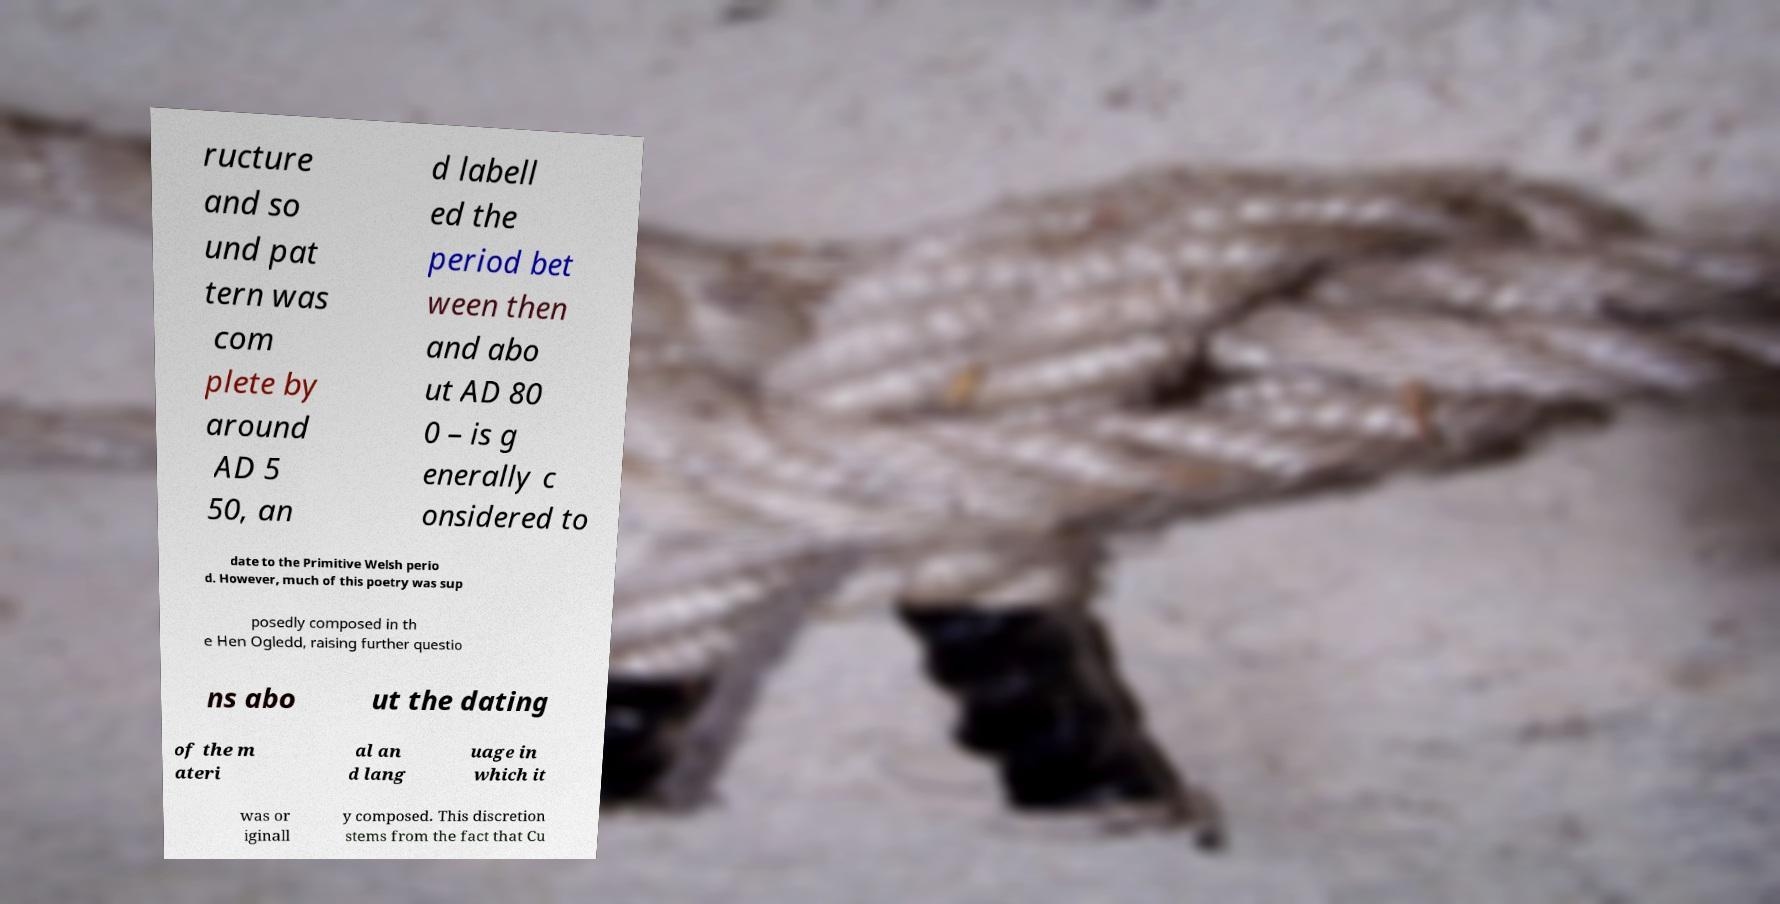Please identify and transcribe the text found in this image. ructure and so und pat tern was com plete by around AD 5 50, an d labell ed the period bet ween then and abo ut AD 80 0 – is g enerally c onsidered to date to the Primitive Welsh perio d. However, much of this poetry was sup posedly composed in th e Hen Ogledd, raising further questio ns abo ut the dating of the m ateri al an d lang uage in which it was or iginall y composed. This discretion stems from the fact that Cu 